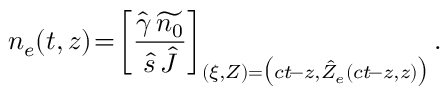Convert formula to latex. <formula><loc_0><loc_0><loc_500><loc_500>n _ { e } ( t , z ) \, = \, \left [ \frac { \hat { \gamma } \, \widetilde { n _ { 0 } } } { \hat { s } \, \hat { J } } \right ] _ { ( \xi , Z ) = \left ( c t \, - z , \hat { Z } _ { e } ( c t \, - z , z ) \right ) } .</formula> 